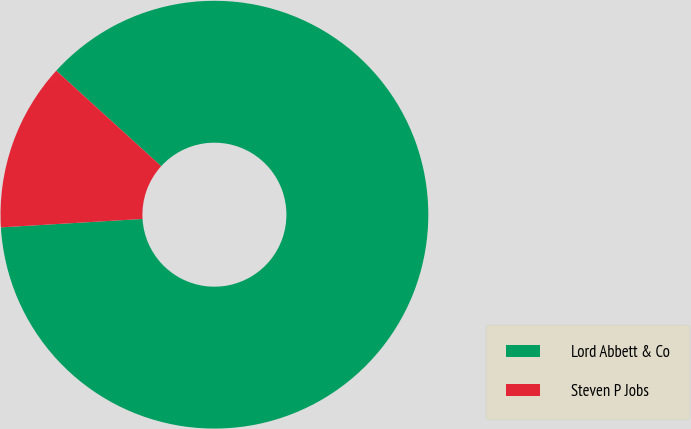<chart> <loc_0><loc_0><loc_500><loc_500><pie_chart><fcel>Lord Abbett & Co<fcel>Steven P Jobs<nl><fcel>87.3%<fcel>12.7%<nl></chart> 